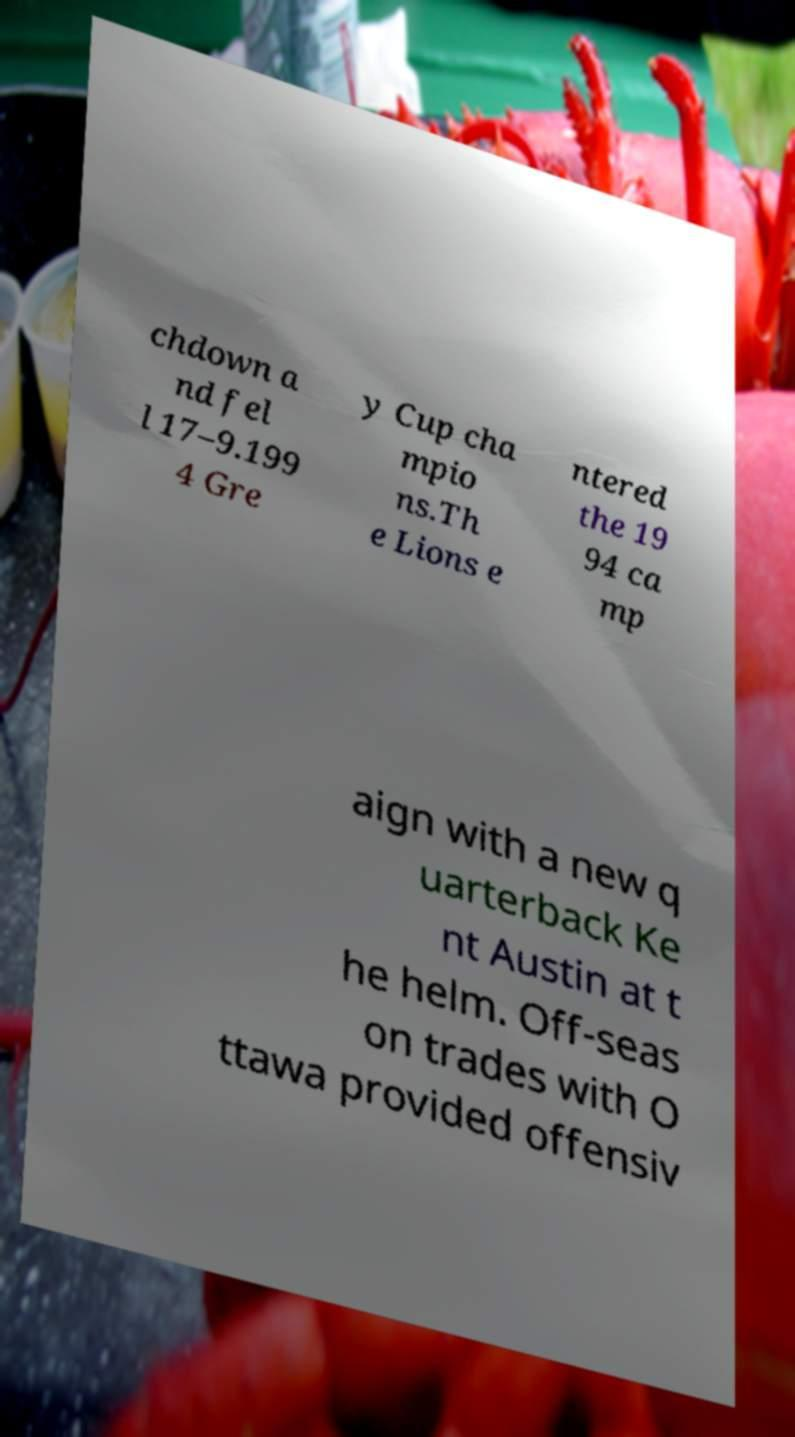I need the written content from this picture converted into text. Can you do that? chdown a nd fel l 17–9.199 4 Gre y Cup cha mpio ns.Th e Lions e ntered the 19 94 ca mp aign with a new q uarterback Ke nt Austin at t he helm. Off-seas on trades with O ttawa provided offensiv 